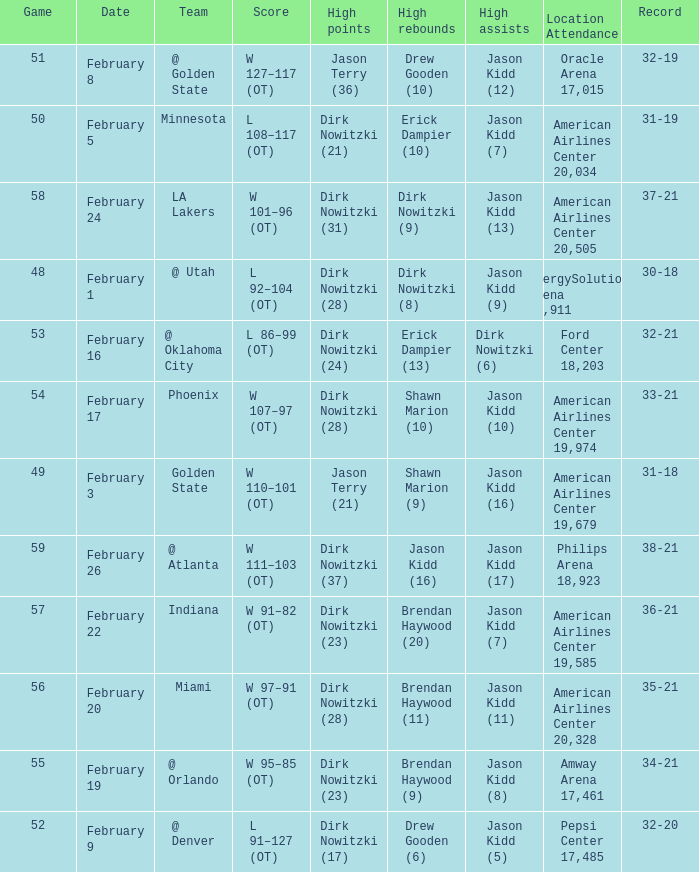When did the Mavericks have a record of 32-19? February 8. 